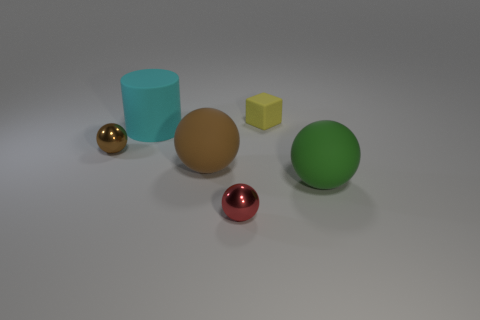Subtract all big green rubber spheres. How many spheres are left? 3 Subtract all brown cubes. How many brown spheres are left? 2 Subtract all red spheres. How many spheres are left? 3 Subtract 1 spheres. How many spheres are left? 3 Add 4 small rubber blocks. How many objects exist? 10 Subtract all yellow balls. Subtract all brown cubes. How many balls are left? 4 Subtract all blocks. How many objects are left? 5 Subtract 0 gray cubes. How many objects are left? 6 Subtract all big metallic cubes. Subtract all metal balls. How many objects are left? 4 Add 2 red things. How many red things are left? 3 